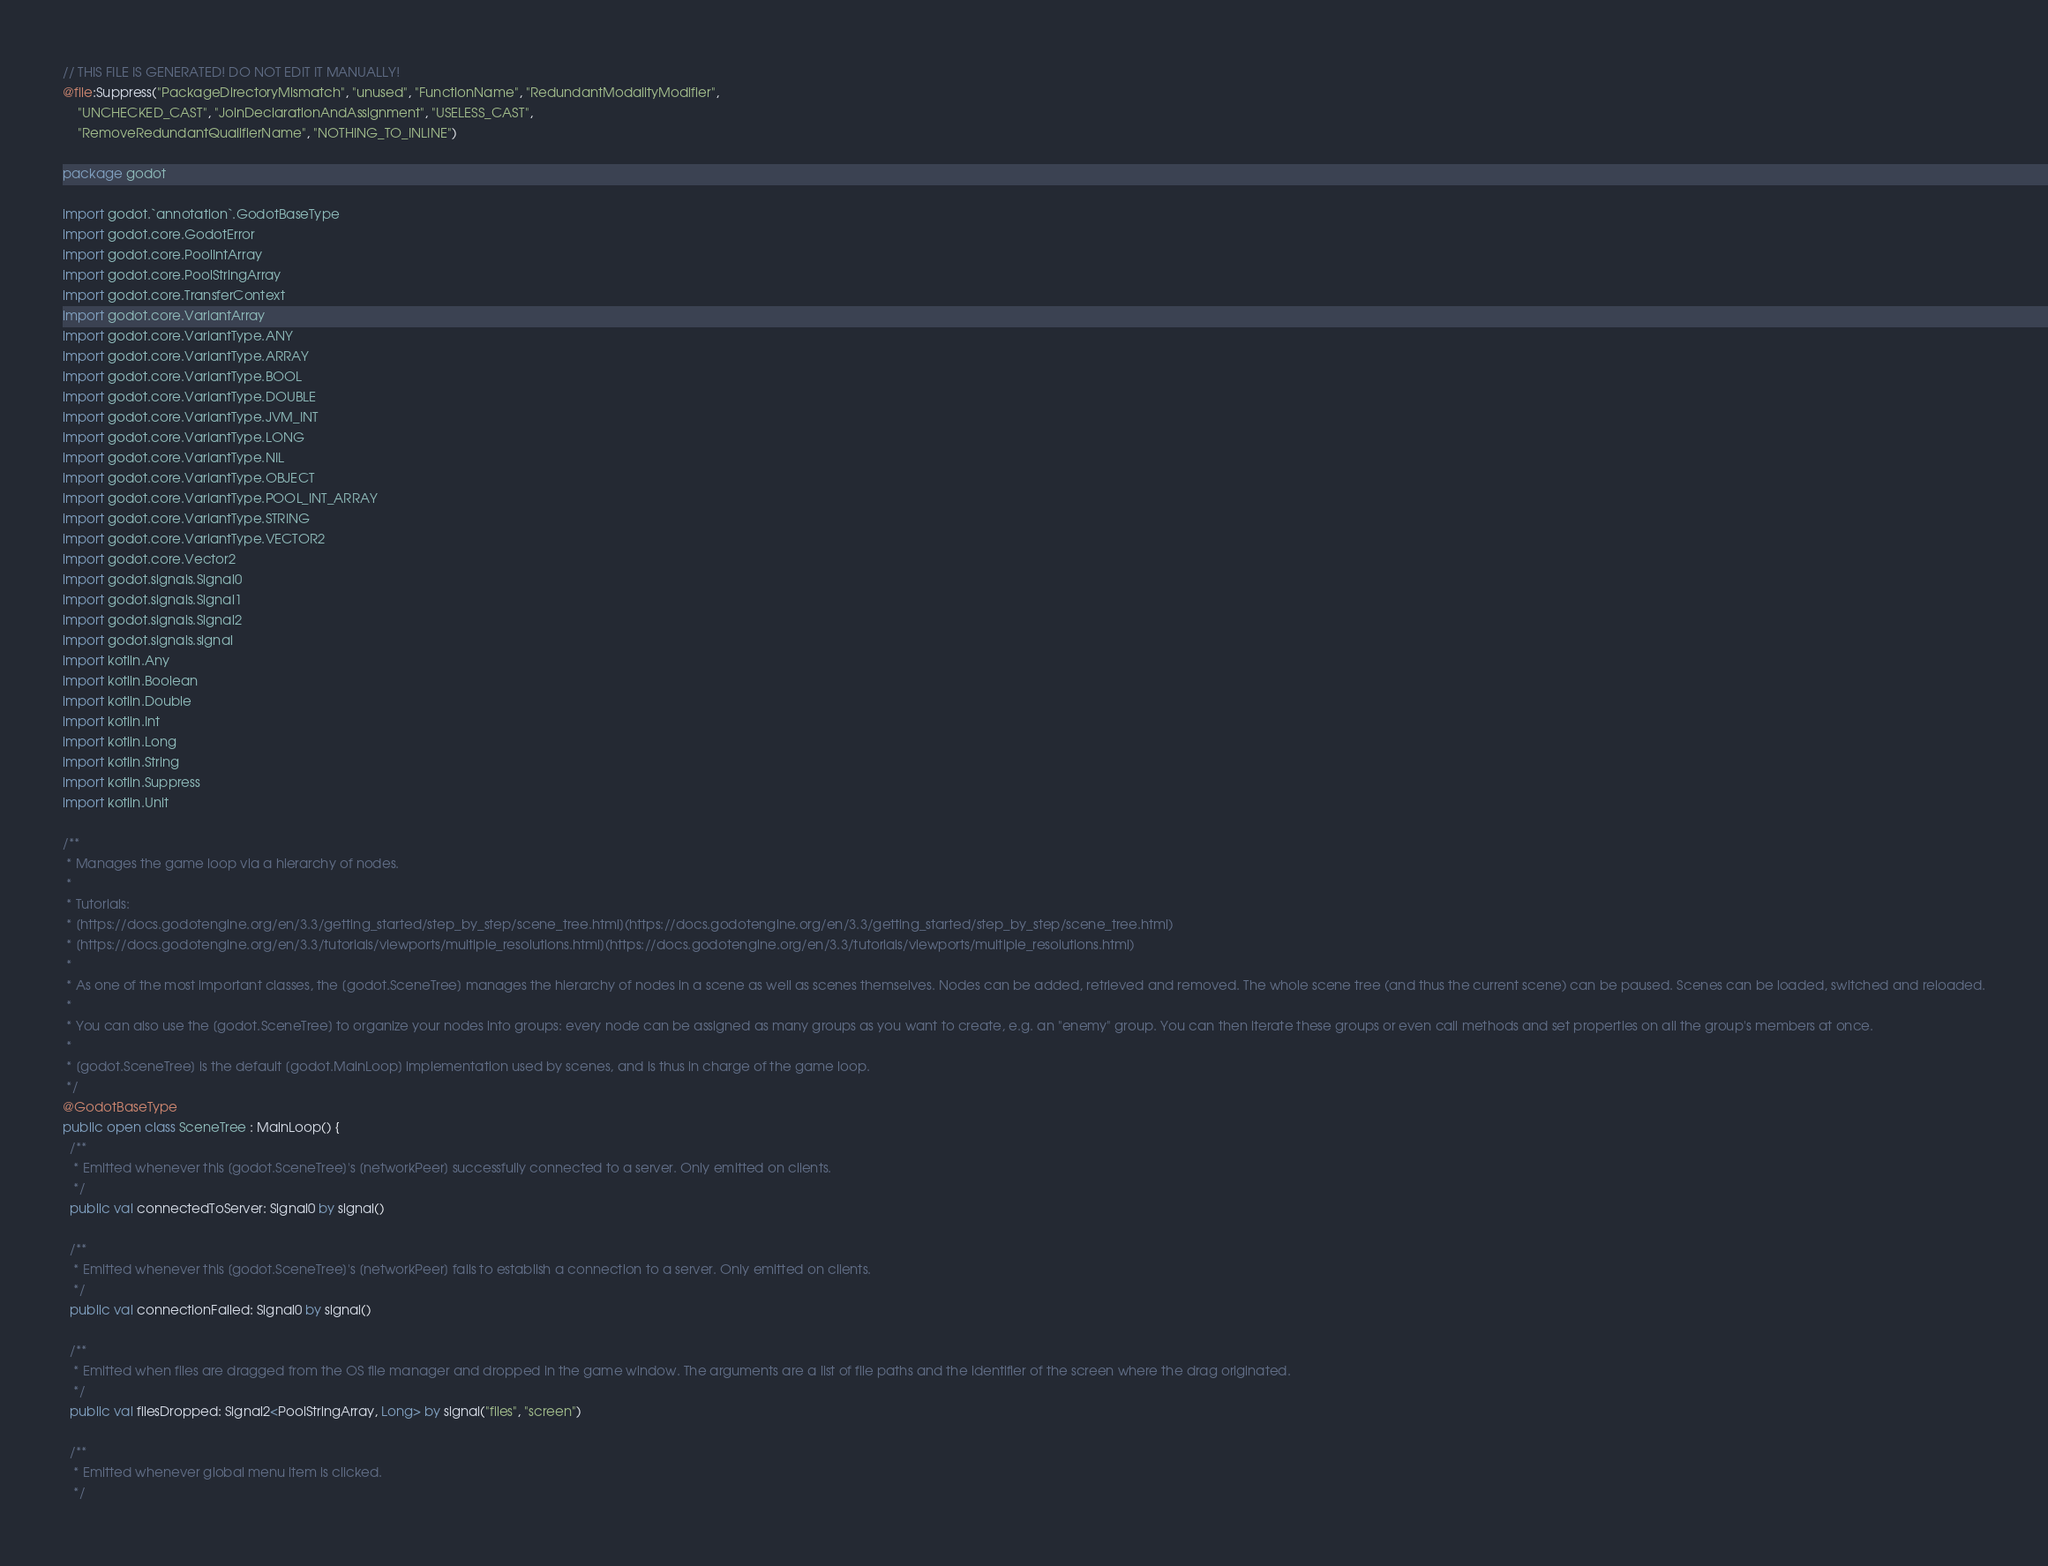<code> <loc_0><loc_0><loc_500><loc_500><_Kotlin_>// THIS FILE IS GENERATED! DO NOT EDIT IT MANUALLY!
@file:Suppress("PackageDirectoryMismatch", "unused", "FunctionName", "RedundantModalityModifier",
    "UNCHECKED_CAST", "JoinDeclarationAndAssignment", "USELESS_CAST",
    "RemoveRedundantQualifierName", "NOTHING_TO_INLINE")

package godot

import godot.`annotation`.GodotBaseType
import godot.core.GodotError
import godot.core.PoolIntArray
import godot.core.PoolStringArray
import godot.core.TransferContext
import godot.core.VariantArray
import godot.core.VariantType.ANY
import godot.core.VariantType.ARRAY
import godot.core.VariantType.BOOL
import godot.core.VariantType.DOUBLE
import godot.core.VariantType.JVM_INT
import godot.core.VariantType.LONG
import godot.core.VariantType.NIL
import godot.core.VariantType.OBJECT
import godot.core.VariantType.POOL_INT_ARRAY
import godot.core.VariantType.STRING
import godot.core.VariantType.VECTOR2
import godot.core.Vector2
import godot.signals.Signal0
import godot.signals.Signal1
import godot.signals.Signal2
import godot.signals.signal
import kotlin.Any
import kotlin.Boolean
import kotlin.Double
import kotlin.Int
import kotlin.Long
import kotlin.String
import kotlin.Suppress
import kotlin.Unit

/**
 * Manages the game loop via a hierarchy of nodes.
 *
 * Tutorials:
 * [https://docs.godotengine.org/en/3.3/getting_started/step_by_step/scene_tree.html](https://docs.godotengine.org/en/3.3/getting_started/step_by_step/scene_tree.html)
 * [https://docs.godotengine.org/en/3.3/tutorials/viewports/multiple_resolutions.html](https://docs.godotengine.org/en/3.3/tutorials/viewports/multiple_resolutions.html)
 *
 * As one of the most important classes, the [godot.SceneTree] manages the hierarchy of nodes in a scene as well as scenes themselves. Nodes can be added, retrieved and removed. The whole scene tree (and thus the current scene) can be paused. Scenes can be loaded, switched and reloaded.
 *
 * You can also use the [godot.SceneTree] to organize your nodes into groups: every node can be assigned as many groups as you want to create, e.g. an "enemy" group. You can then iterate these groups or even call methods and set properties on all the group's members at once.
 *
 * [godot.SceneTree] is the default [godot.MainLoop] implementation used by scenes, and is thus in charge of the game loop.
 */
@GodotBaseType
public open class SceneTree : MainLoop() {
  /**
   * Emitted whenever this [godot.SceneTree]'s [networkPeer] successfully connected to a server. Only emitted on clients.
   */
  public val connectedToServer: Signal0 by signal()

  /**
   * Emitted whenever this [godot.SceneTree]'s [networkPeer] fails to establish a connection to a server. Only emitted on clients.
   */
  public val connectionFailed: Signal0 by signal()

  /**
   * Emitted when files are dragged from the OS file manager and dropped in the game window. The arguments are a list of file paths and the identifier of the screen where the drag originated.
   */
  public val filesDropped: Signal2<PoolStringArray, Long> by signal("files", "screen")

  /**
   * Emitted whenever global menu item is clicked.
   */</code> 